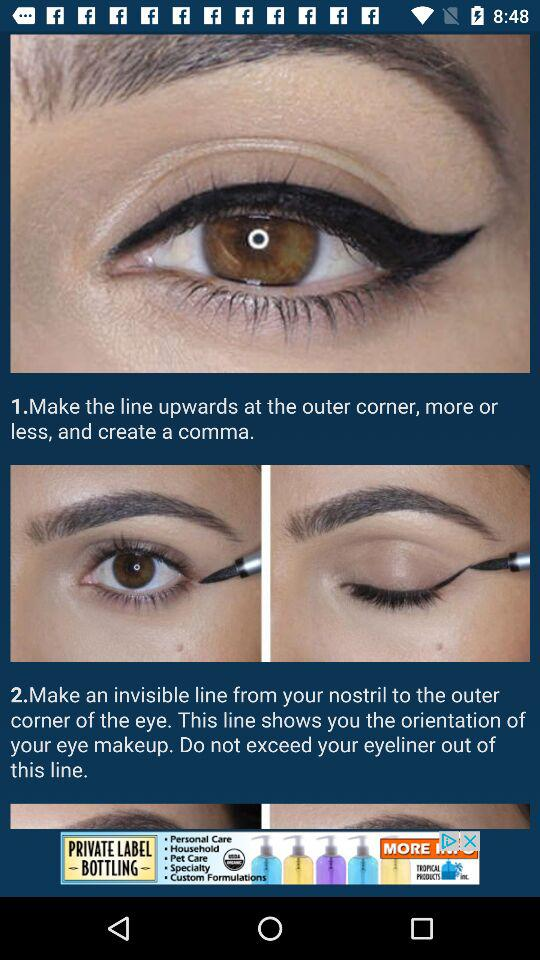How many steps are there in the eyeliner tutorial?
Answer the question using a single word or phrase. 2 